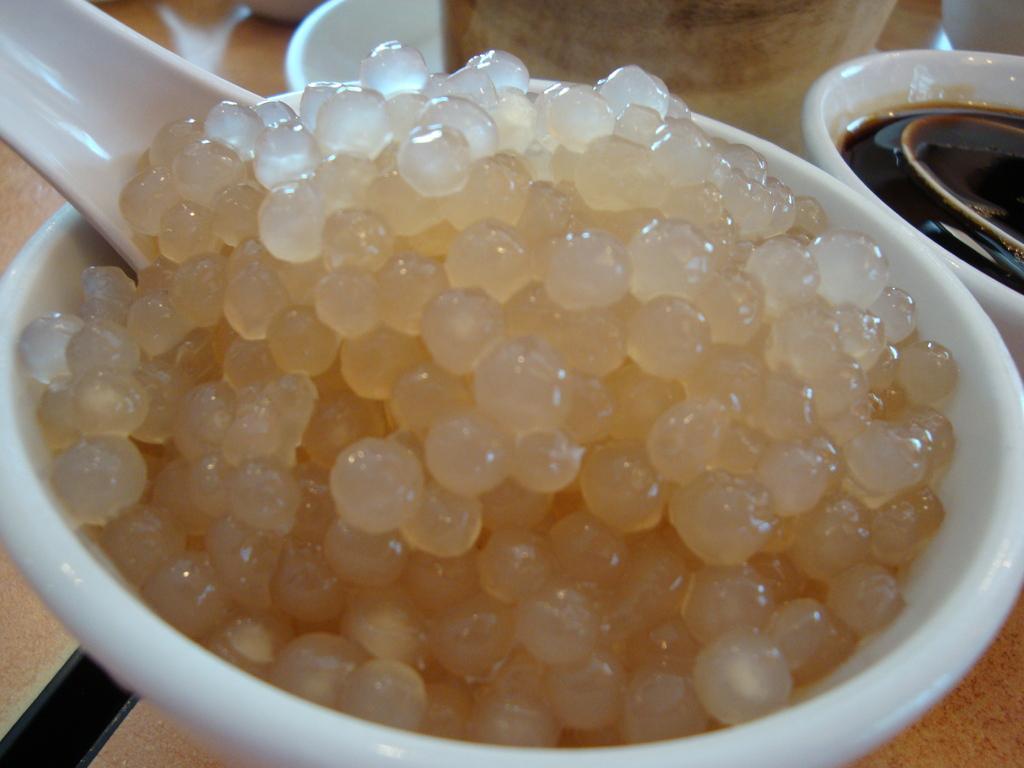Could you give a brief overview of what you see in this image? In the center of this picture we can see a white color bowl containing some food item which seems to be a sago and a white color object which seems to be the spoon. In the background we can see some other objects and some food items and the wooden object seems to be the table. 